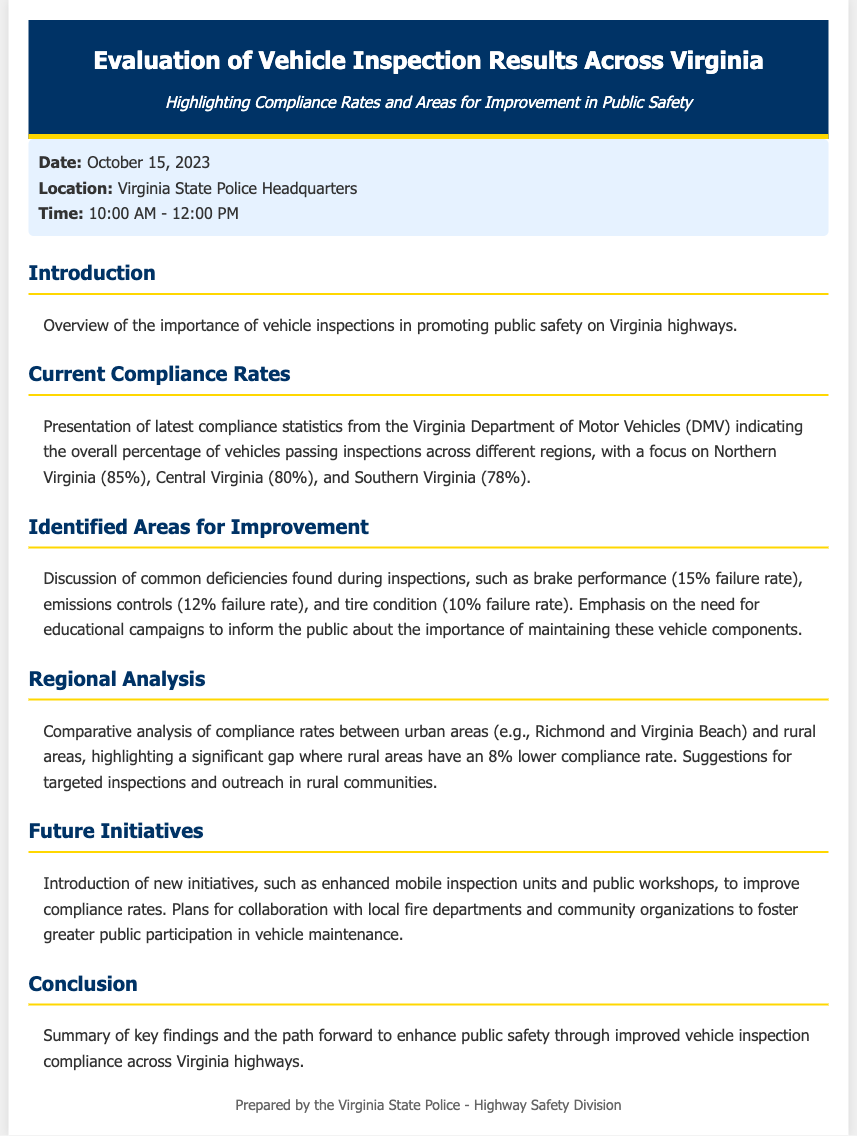what is the date of the evaluation? The date mentioned for the evaluation is October 15, 2023.
Answer: October 15, 2023 what is the compliance rate for Northern Virginia? The document states that Northern Virginia has a compliance rate of 85%.
Answer: 85% which area has the lowest compliance rate? The analysis indicates that Southern Virginia has the lowest compliance rate at 78%.
Answer: Southern Virginia what common deficiency has a 15% failure rate? The document mentions that brake performance has a 15% failure rate.
Answer: brake performance what is the suggested compliance improvement for rural areas? The document suggests targeted inspections and outreach in rural communities to improve compliance rates.
Answer: targeted inspections and outreach who is preparing the document? The footer indicates that the document is prepared by the Virginia State Police - Highway Safety Division.
Answer: Virginia State Police - Highway Safety Division what initiatives are introduced to improve compliance rates? The document mentions new initiatives such as enhanced mobile inspection units and public workshops.
Answer: enhanced mobile inspection units and public workshops what is the compliance rate difference between urban and rural areas? The document highlights a significant gap where rural areas have an 8% lower compliance rate compared to urban areas.
Answer: 8% lower 